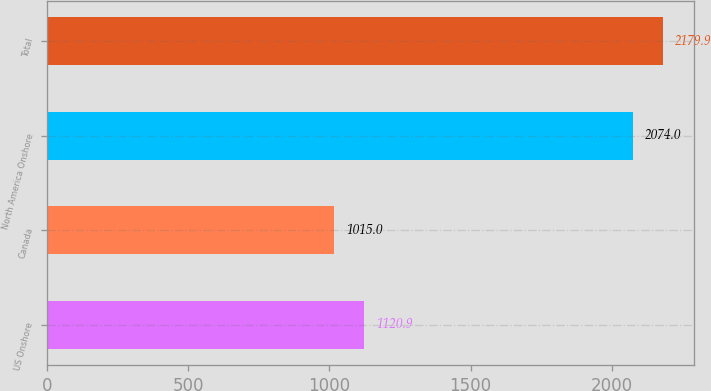Convert chart to OTSL. <chart><loc_0><loc_0><loc_500><loc_500><bar_chart><fcel>US Onshore<fcel>Canada<fcel>North America Onshore<fcel>Total<nl><fcel>1120.9<fcel>1015<fcel>2074<fcel>2179.9<nl></chart> 